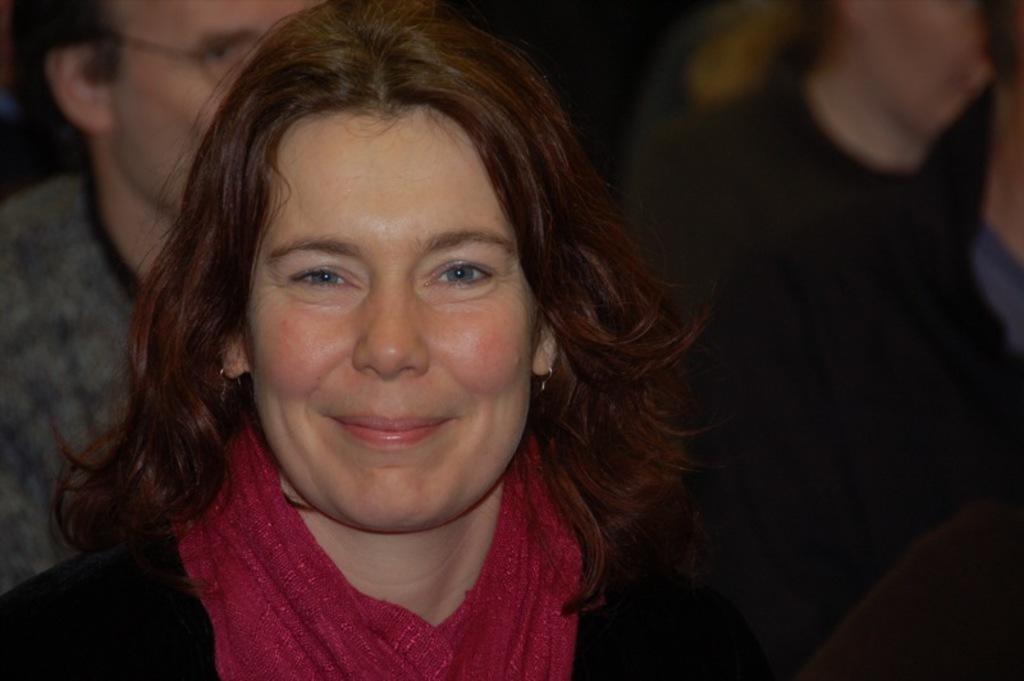Could you give a brief overview of what you see in this image? In the foreground of this image, there is a woman wearing black dress and a red stole. In the background, there are two people. 